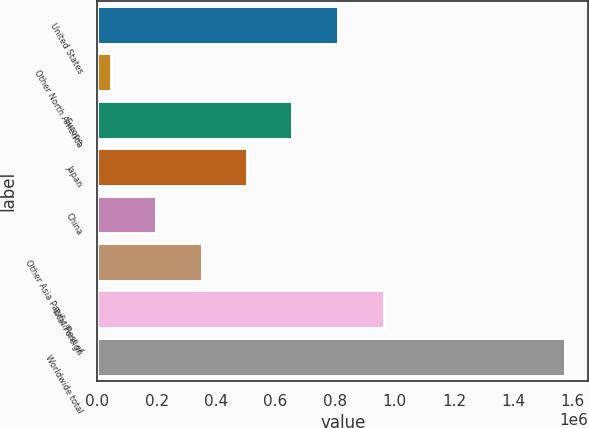<chart> <loc_0><loc_0><loc_500><loc_500><bar_chart><fcel>United States<fcel>Other North America<fcel>Europe<fcel>Japan<fcel>China<fcel>Other Asia Pacific/Rest of<fcel>Total Foreign<fcel>Worldwide total<nl><fcel>809369<fcel>45505<fcel>656596<fcel>503823<fcel>198278<fcel>351051<fcel>963629<fcel>1.57323e+06<nl></chart> 